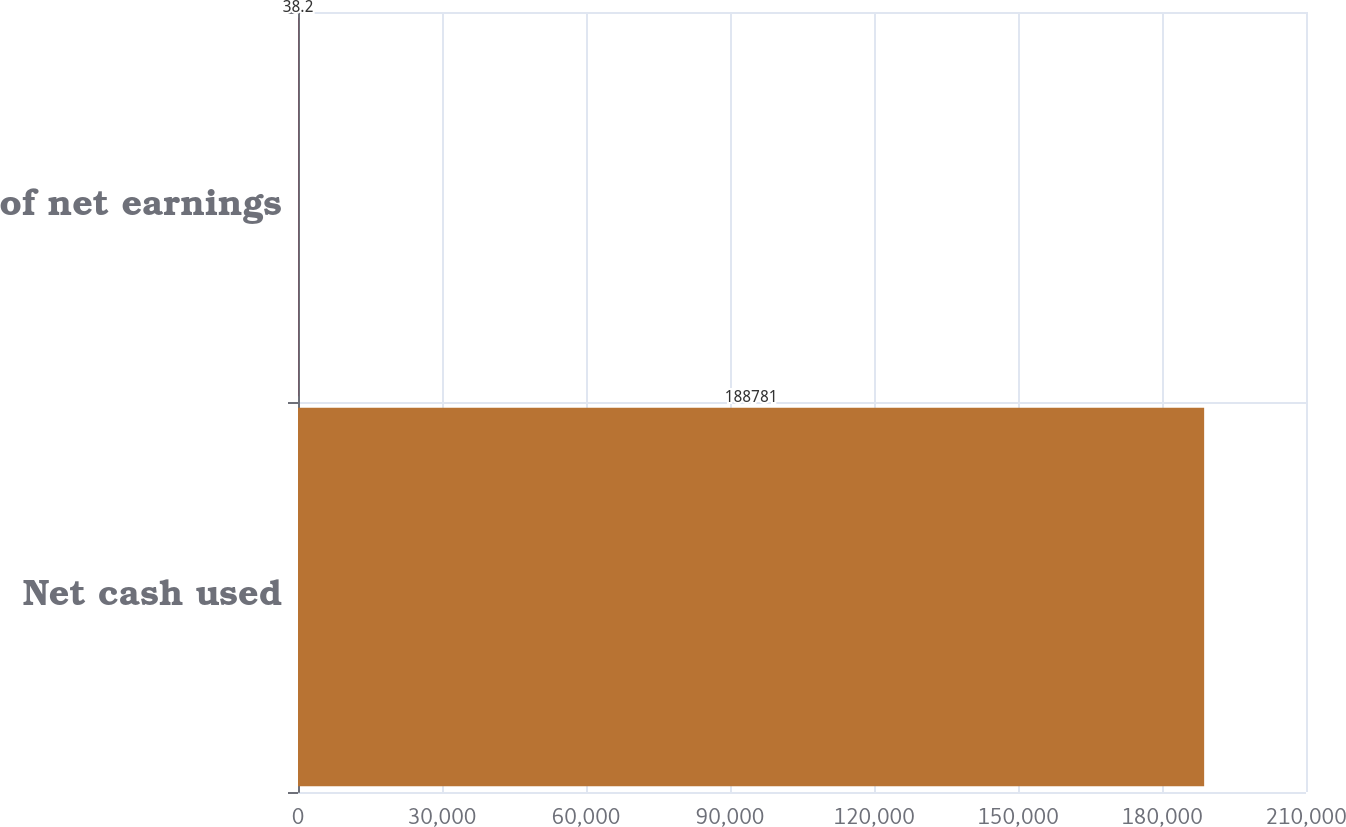Convert chart to OTSL. <chart><loc_0><loc_0><loc_500><loc_500><bar_chart><fcel>Net cash used<fcel>of net earnings<nl><fcel>188781<fcel>38.2<nl></chart> 